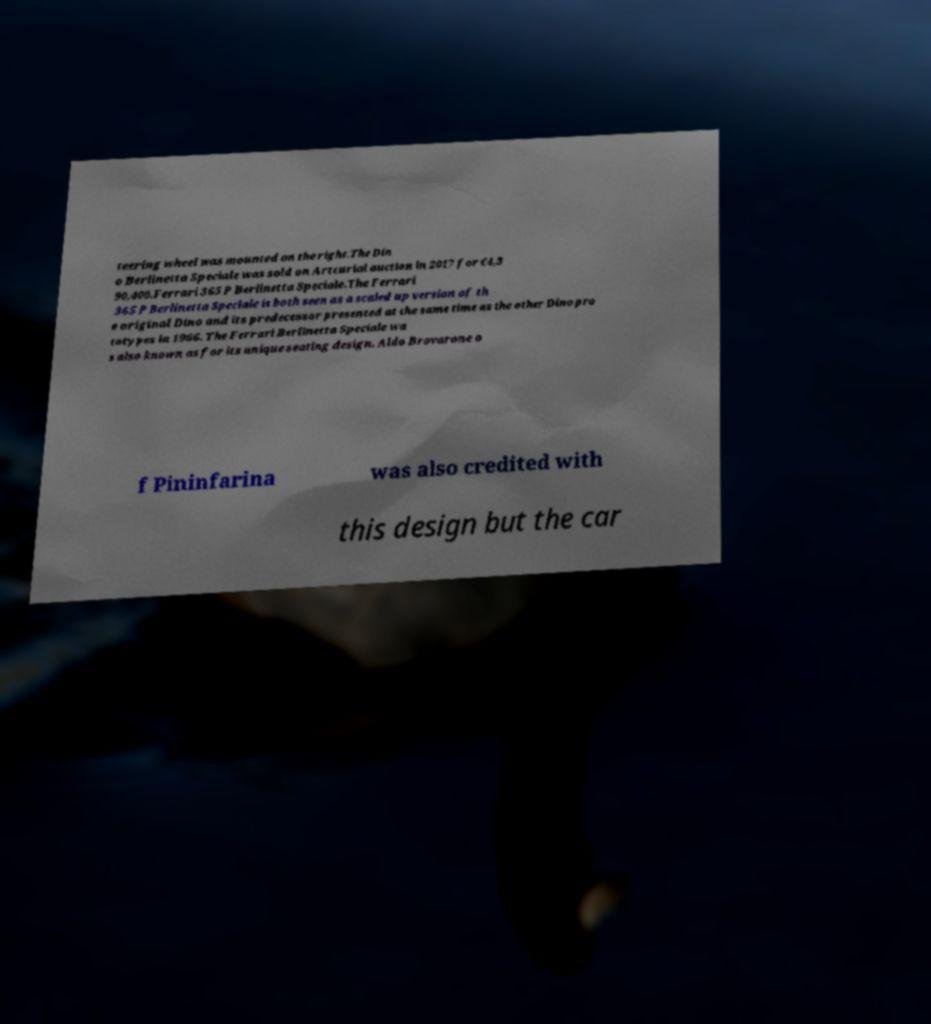Please read and relay the text visible in this image. What does it say? teering wheel was mounted on the right.The Din o Berlinetta Speciale was sold on Artcurial auction in 2017 for €4,3 90,400.Ferrari 365 P Berlinetta Speciale.The Ferrari 365 P Berlinetta Speciale is both seen as a scaled up version of th e original Dino and its predecessor presented at the same time as the other Dino pro totypes in 1966. The Ferrari Berlinetta Speciale wa s also known as for its unique seating design. Aldo Brovarone o f Pininfarina was also credited with this design but the car 